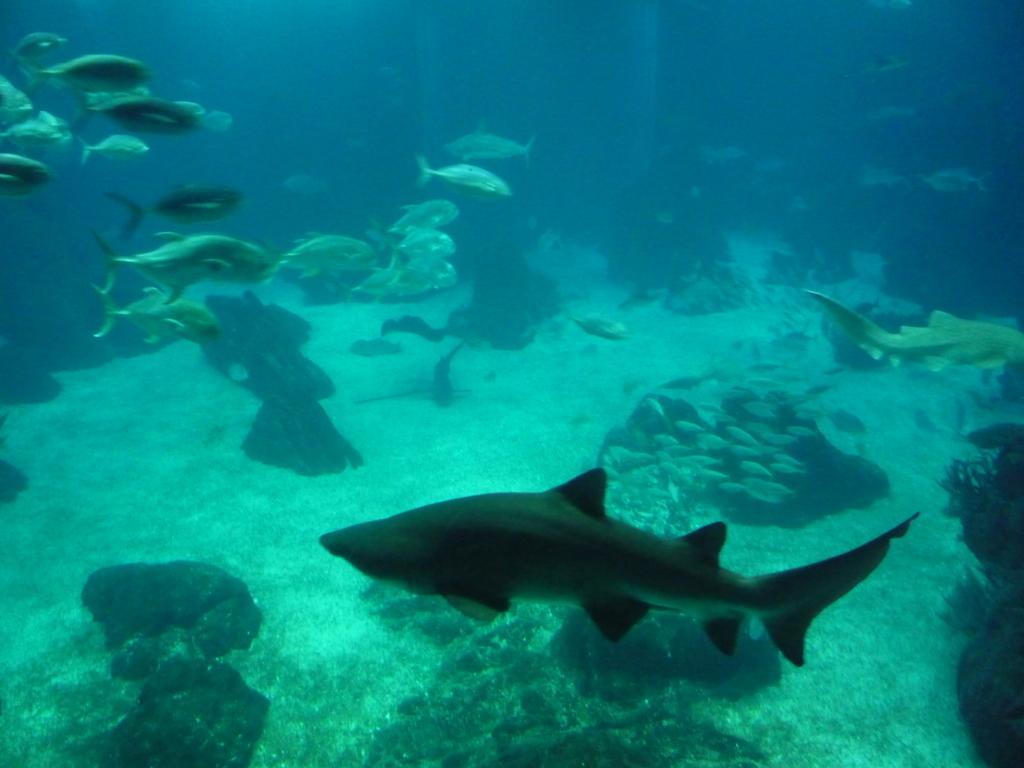Can you describe this image briefly? In this picture we can see the group of fishes and some marine creatures swimming in the water and we can see the rocks and some other objects. 